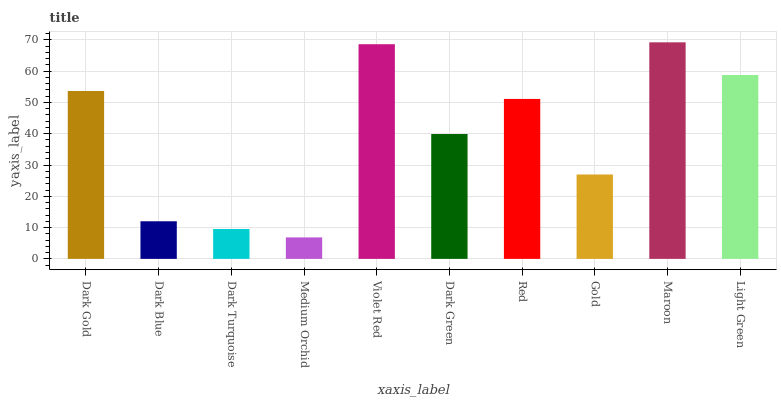Is Medium Orchid the minimum?
Answer yes or no. Yes. Is Maroon the maximum?
Answer yes or no. Yes. Is Dark Blue the minimum?
Answer yes or no. No. Is Dark Blue the maximum?
Answer yes or no. No. Is Dark Gold greater than Dark Blue?
Answer yes or no. Yes. Is Dark Blue less than Dark Gold?
Answer yes or no. Yes. Is Dark Blue greater than Dark Gold?
Answer yes or no. No. Is Dark Gold less than Dark Blue?
Answer yes or no. No. Is Red the high median?
Answer yes or no. Yes. Is Dark Green the low median?
Answer yes or no. Yes. Is Medium Orchid the high median?
Answer yes or no. No. Is Medium Orchid the low median?
Answer yes or no. No. 